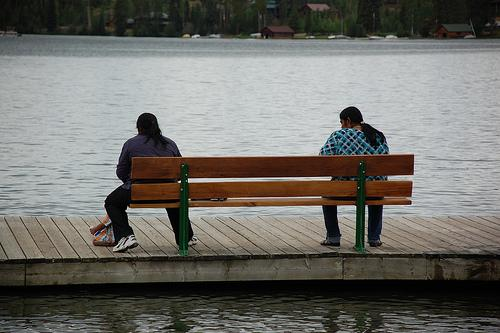Deduce how many benches are actually in the image based on the given information. There is likely one wooden bench in the image, with different perspectives and descriptions provided in the information. Count the people in the image and mention their attire color. There are two women, one wearing a blue checkered shirt and the other in a black shirt and pants. In the context of the picture, explain how the green pole and the bench are related to each other. The green pole appears to be positioned behind the brown bench, possibly on the same wooden dock. Provide some observations about the bench placed at the scene. The bench is a wooden, brown bench positioned on a dock, with a green pole behind it and two women sitting on it. Evaluate the emotion or sentiment conveyed by the scene in the image. The scene conveys a calm and peaceful sentiment, with the placid water and people sitting on a bench. Identify the primary colors seen in the clothes worn by the people in the image. Primary colors in the clothes are blue and black. Analyze the image and describe any water features presented. The image shows a placid body of water with ripples, reflections, and a wooden dock situated on it. Briefly describe the two women in the image. The first woman has a ponytail and wears a blue checkered shirt, while the second woman wears a black shirt and black pants. Examine the picture and mention the type of water body shown. The image shows a large body of water, possibly a lake. List the types of objects that can be found in the image. Objects include a wooden bench, a wooden dock, two women, and a green pole. Which of the following choices describes the image best? A) Two women in a park, B) Two women by a river, C) Two women on a dock. C) Two women on a dock Is there any object that seems out of context in the image? No, all objects are in context. What's written on the signpost near the green pole in the back of the bench? Share your thoughts on why it's placed there. No, it's not mentioned in the image. Give a caption for the image containing the main objects. Two women sitting on a wooden bench on a dock by a placid body of water. Is there anything unusual or out of place in the image? No, everything seems normal. Describe the attributes of the woman at position X:315 Y:98. has a ponytail, wearing a blue checkered shirt Describe the boundaries of the large body of water at X:211 Y:71. Width: 80, Height: 80 Evaluate the overall quality of the image. Is it sharp, focused, or blurry? The image quality is sharp and focused. Identify and classify the objects in the image. placid body of water, wooden dock, two women, wooden bench, green pole What is the sentiment conveyed by the image? calm and serene What color is the pole in the image? green What is the relationship between the water and the dock? The dock is on the water. Assess the image quality. good and clear Choose the true statement: A) The women are standing by the water, B) The women are sitting on a bench, C) The women are wearing hats. B) The women are sitting on a bench Which object is referred to as "a bench" with position X:256 Y:87? The object is a bench located near two women. Identify the object at position X:311 Y:100 in the image. woman in a blue striped shirt Are there any visible text or characters in the image? No, there aren't any. How are the two women interacting with the bench? sitting on it Do you believe the man standing far away and watching the lake is enjoying the view? Also, elaborate on the colors he is wearing. No man is mentioned in the list of objects present in the image. The viewer is being misled by asking about a non-existent person's thoughts and clothes. Observe the small dog playing on the wooden dock and share your thoughts about its behavior. No dog is mentioned in the provided objects' information. This instruction misleads the viewer by making them think there's a dog in the image. Count how many benches are present in the image. 1 bench What is the focal point of the image? two women sitting on the wooden bench 